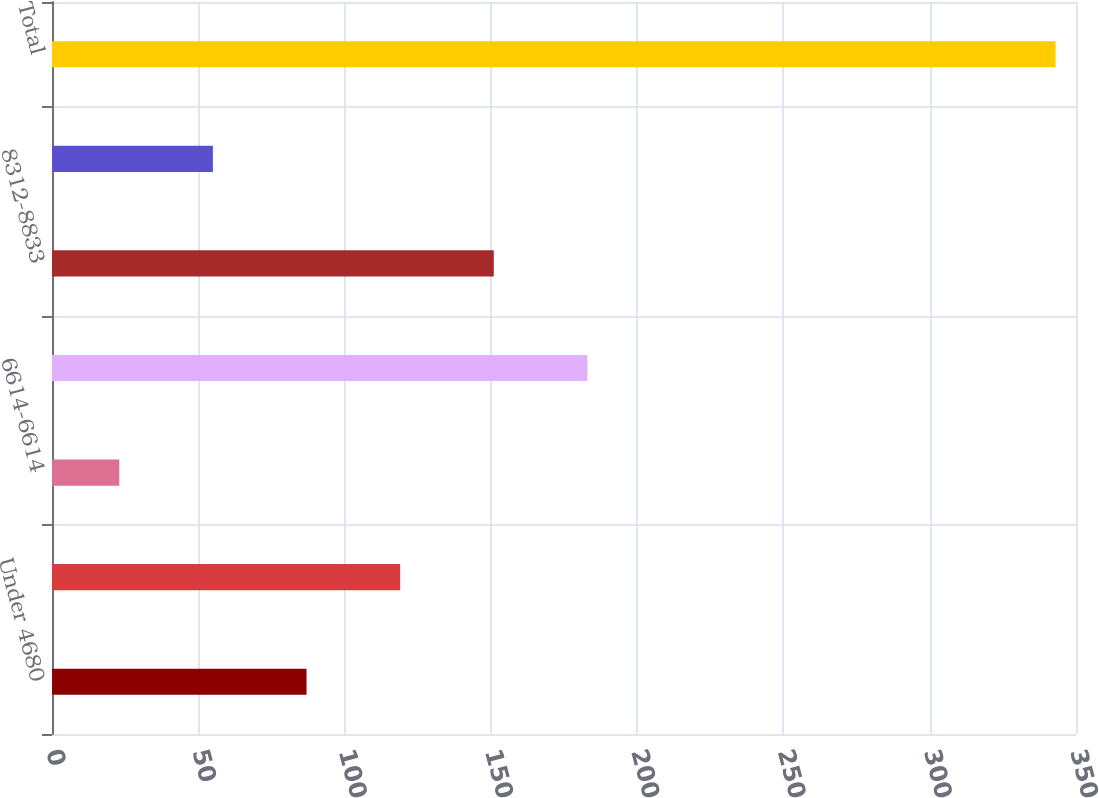Convert chart. <chart><loc_0><loc_0><loc_500><loc_500><bar_chart><fcel>Under 4680<fcel>5734-5734<fcel>6614-6614<fcel>6995-8190<fcel>8312-8833<fcel>8946-9365<fcel>Total<nl><fcel>87<fcel>119<fcel>23<fcel>183<fcel>151<fcel>55<fcel>343<nl></chart> 